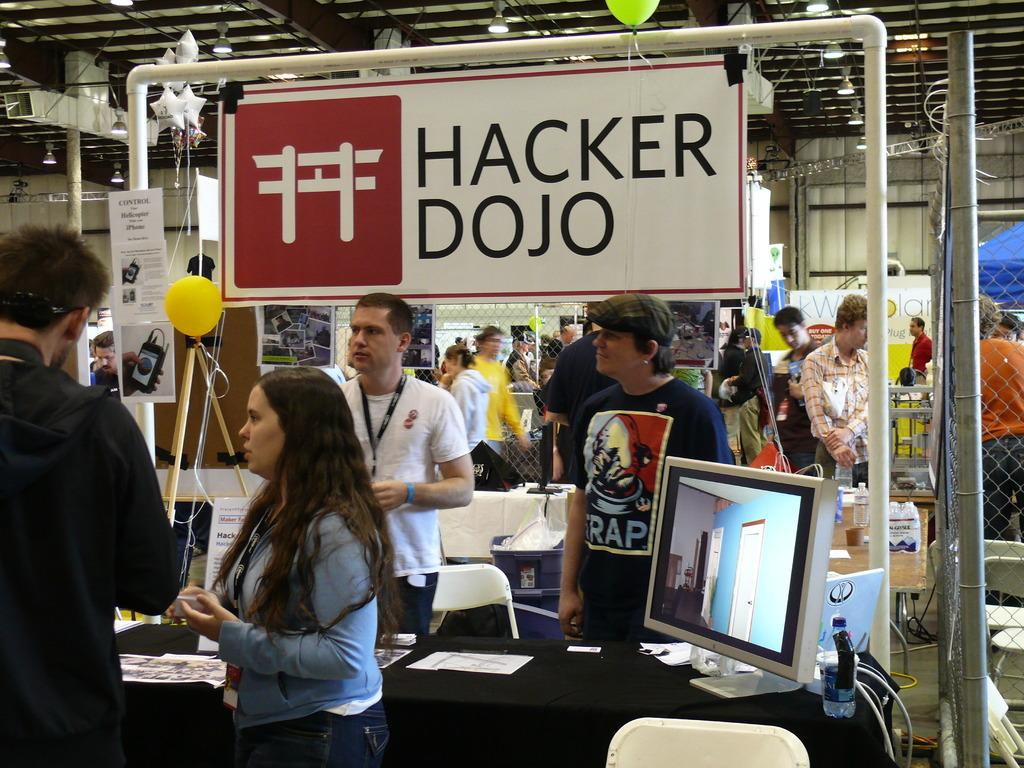What is the main subject of the image? There is a woman standing in the center of the image. What is the woman doing in the image? The woman is speaking. How many people are in the center of the image? There are two people standing in the center of the image. How many people can be seen in the background of the image? There are six people visible in the background of the image. What type of pain can be seen on the woman's face in the image? There is no indication of pain on the woman's face in the image. Is there a stream visible in the background of the image? There is no stream present in the image. 